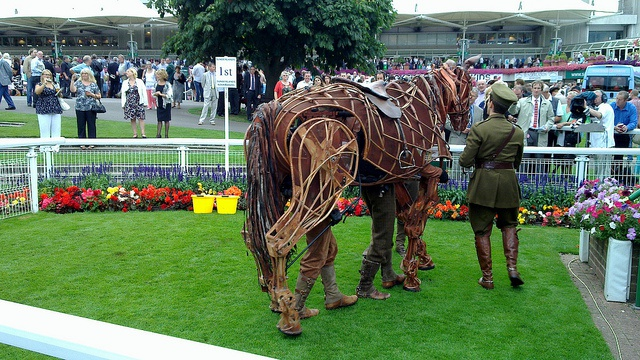Describe the objects in this image and their specific colors. I can see horse in white, black, maroon, and gray tones, people in white, black, gray, darkgray, and lightgray tones, people in white, black, gray, darkgreen, and maroon tones, potted plant in white, lightblue, black, gray, and darkgreen tones, and people in white, black, gray, and maroon tones in this image. 